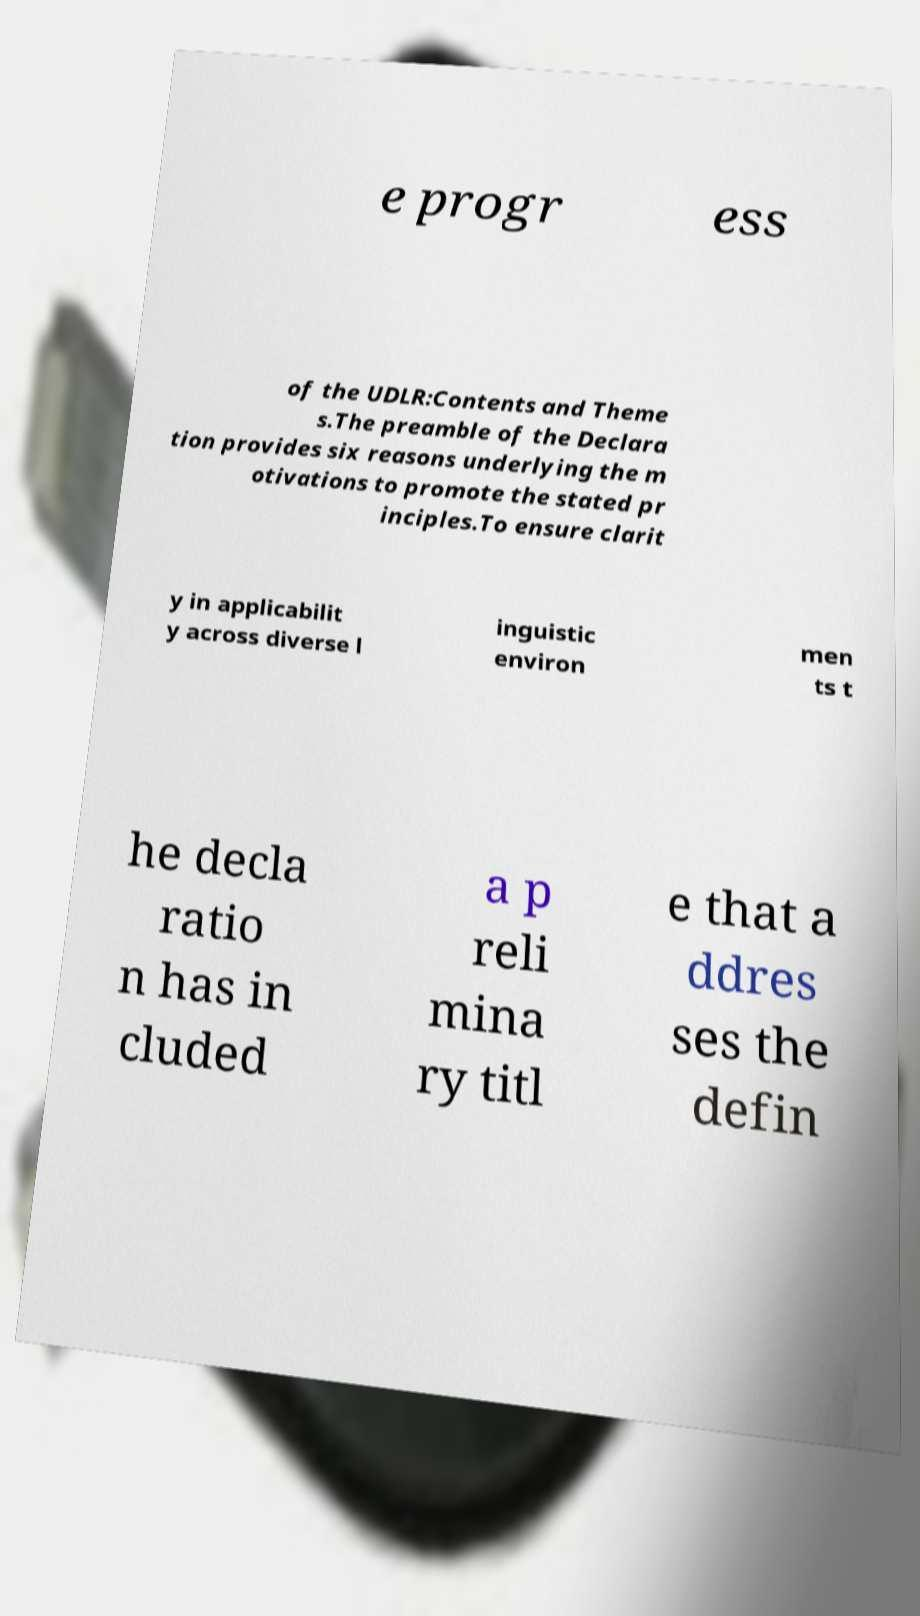Can you read and provide the text displayed in the image?This photo seems to have some interesting text. Can you extract and type it out for me? e progr ess of the UDLR:Contents and Theme s.The preamble of the Declara tion provides six reasons underlying the m otivations to promote the stated pr inciples.To ensure clarit y in applicabilit y across diverse l inguistic environ men ts t he decla ratio n has in cluded a p reli mina ry titl e that a ddres ses the defin 